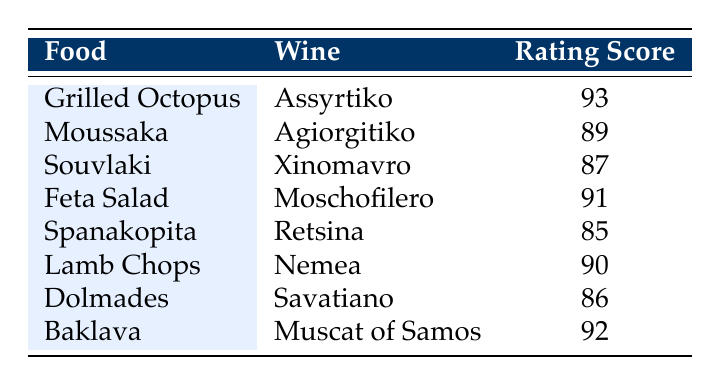What is the rating score for Grilled Octopus? The table lists "Grilled Octopus" paired with "Assyrtiko" and has a corresponding rating score of 93.
Answer: 93 Which wine has the highest rating score? Looking through the rating scores listed, "Assyrtiko" paired with "Grilled Octopus" has the highest score of 93.
Answer: Assyrtiko What is the average rating score of all food pairs? To find the average, we add the rating scores (93 + 89 + 87 + 91 + 85 + 90 + 86 + 92 = 912) and then divide by the number of food pairings (8). Thus, the average is 912/8 = 114.
Answer: 114 Is Baklava paired with a higher rating wine than Spanakopita? The rating for Baklava, paired with "Muscat of Samos," is 92, while Spanakopita paired with "Retsina" has a rating of 85. Since 92 > 85, the answer is yes.
Answer: Yes What is the total rating score of wines paired with meat dishes (Lamb Chops and Souvlaki)? The total for meat dishes is calculated by adding "Lamb Chops" (90) and "Souvlaki" (87), thus 90 + 87 = 177.
Answer: 177 Which food has a rating score of 89, and what wine is it paired with? The food item with a rating score of 89 is "Moussaka," and it is paired with the wine "Agiorgitiko."
Answer: Moussaka, Agiorgitiko How many food pairings have a rating score of 90 or higher? By reviewing the scores, we find 5 food pairings with scores of 90 or higher: Grilled Octopus (93), Feta Salad (91), Baklava (92), Lamb Chops (90), and Moussaka (89). Thus, we conclude there are 5 pairings in this category.
Answer: 5 Are there any wines with a rating score below 90? Examining the table, the food pairings that have ratings below 90 are Spanakopita (85), Dolmades (86), and Souvlaki (87). Hence, the answer is yes, there are wines below 90.
Answer: Yes 